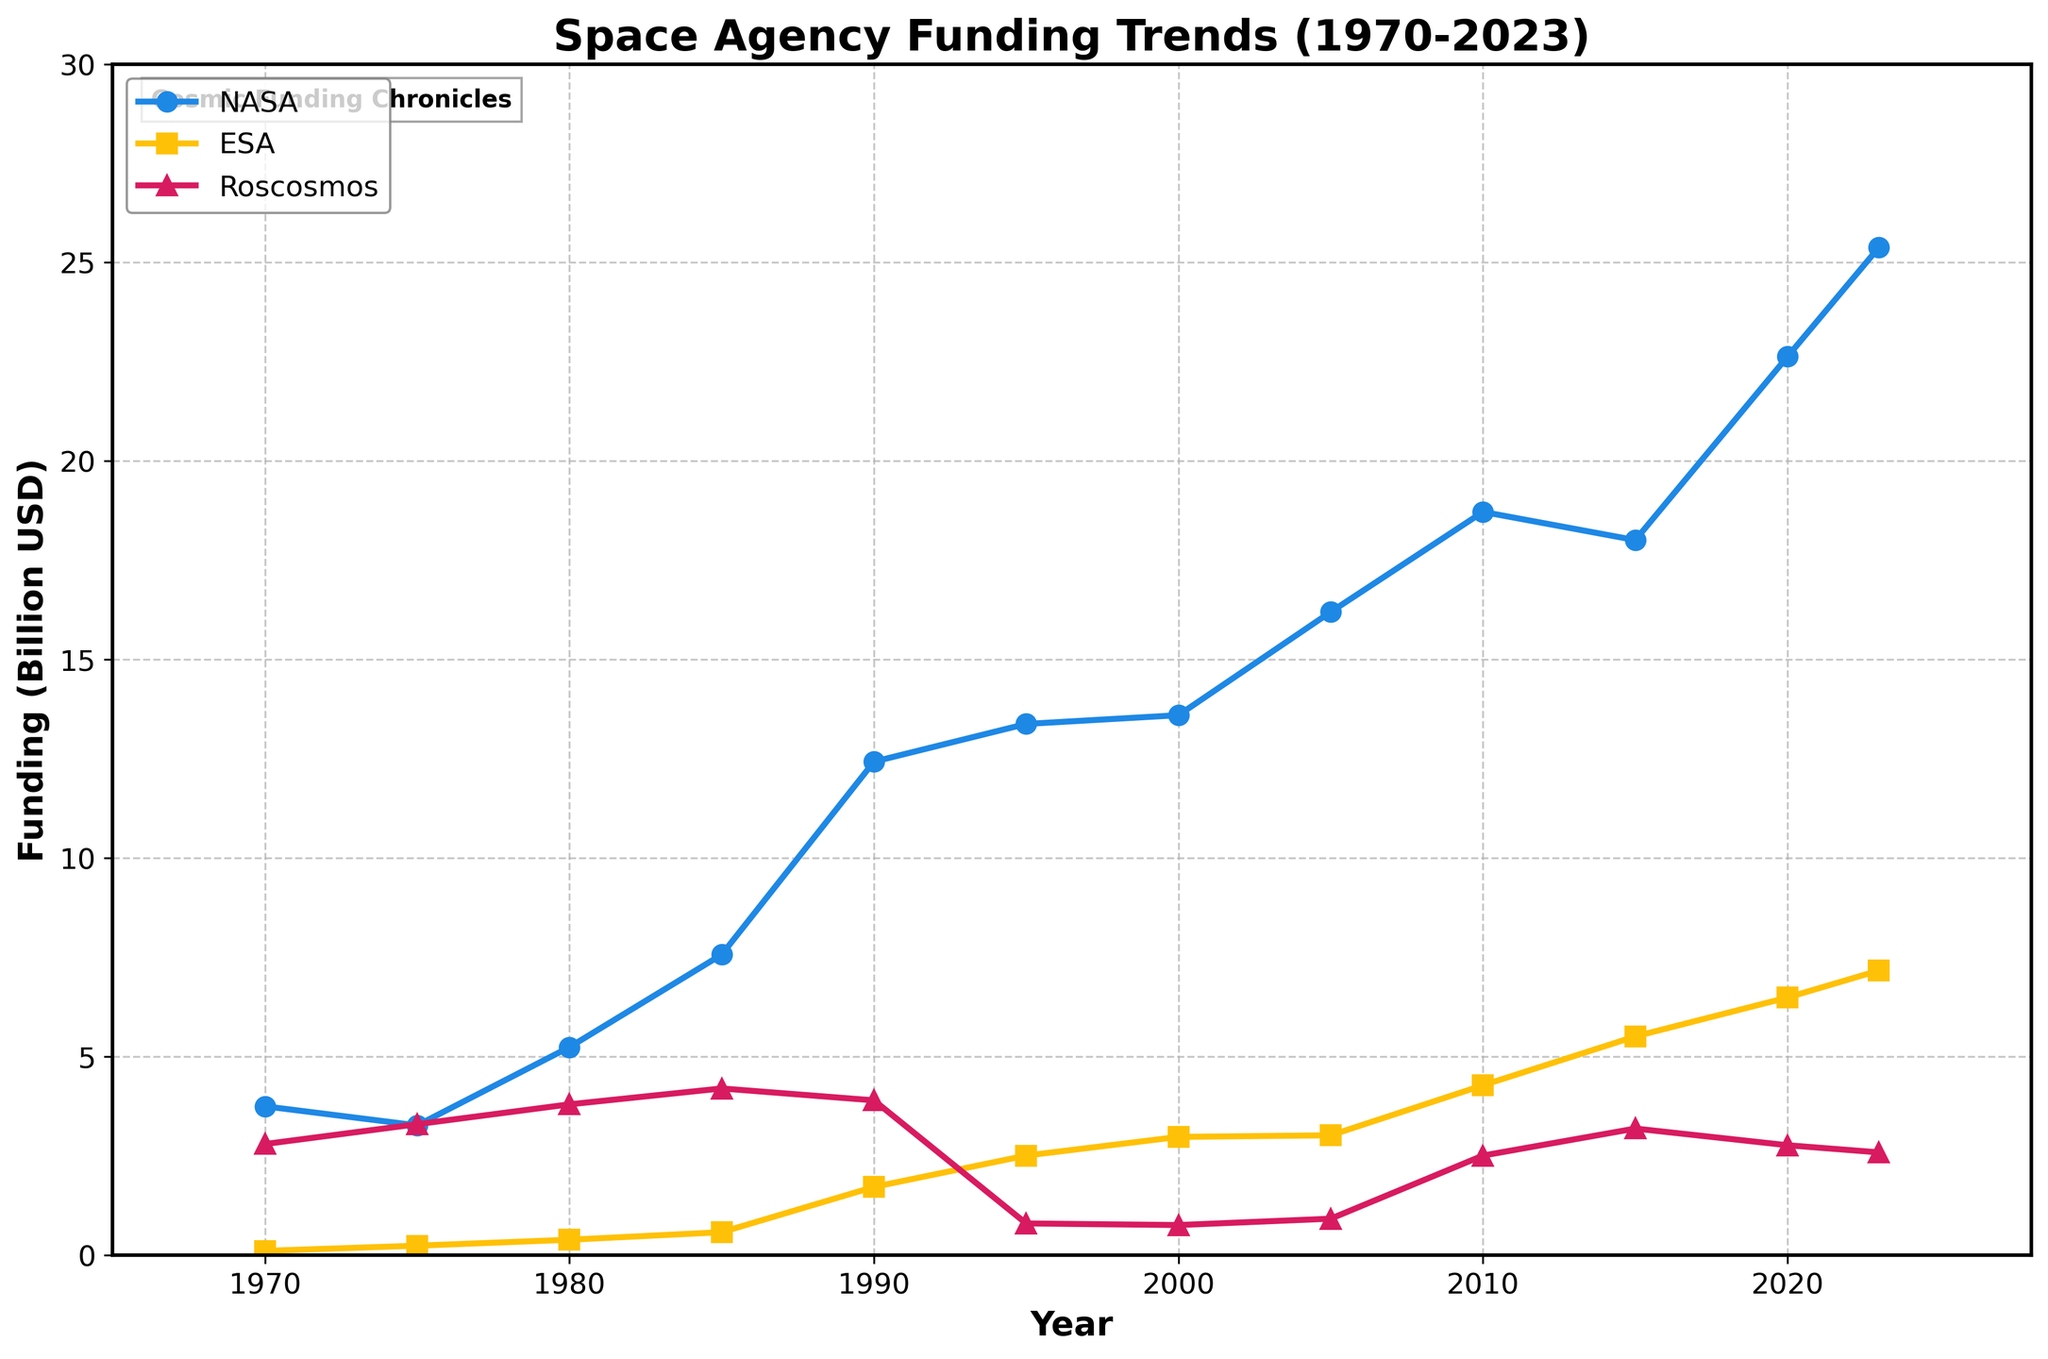What is the trend of NASA's funding from 1970 to 2023? The plot shows an upward trend in NASA's funding from around $3.75 billion in 1970 to around $25.38 billion in 2023. The increase is especially pronounced from the early 1990s onwards.
Answer: Upward trend Which agency had the lowest funding in the year 1995? In 1995, Roscosmos had the lowest funding at around $0.80 billion, while NASA and ESA had higher funding amounts.
Answer: Roscosmos How much did ESA's funding increase from 2010 to 2023? In 2010, ESA's funding was around $4.28 billion, and in 2023 it is around $7.17 billion. The difference is $7.17 billion - $4.28 billion = $2.89 billion.
Answer: $2.89 billion Between 1975 and 1985, which agency saw the greatest increase in funding? NASA's funding increased from $3.27 billion in 1975 to $7.57 billion in 1985, showing an increase of $4.30 billion. ESA's increase was $0.34 billion ($0.24 billion to $0.58 billion), and Roscosmos' increase was $0.90 billion ($3.30 billion to $4.20 billion).
Answer: NASA In which year did NASA first exceed $10 billion in funding? According to the plot, NASA's funding first exceeded $10 billion in 1990 with a value of $12.43 billion.
Answer: 1990 Compare the funding of ESA and Roscosmos in 2000. Which agency had higher funding and by how much? In 2000, ESA had $2.98 billion in funding while Roscosmos had $0.76 billion. The difference is $2.98 billion - $0.76 billion = $2.22 billion.
Answer: ESA, by $2.22 billion What is the general trend of Roscosmos' funding after 1990 compared to before 1990? Before 1990, Roscosmos' funding was generally stable or increasing slightly. After 1990, there was a significant drop, reaching its lowest around 1995, followed by a gradual recovery.
Answer: Trend drops after 1990 What is the average funding of ESA from 1970 to 2023? The funding values for ESA from 1970 to 2023 are $0.11, $0.24, $0.39, $0.58, $1.72, $2.51, $2.98, $3.02, $4.28, $5.51, $6.49, and $7.17 billion. Sum is 35.00 billion. There are 12 values. Average = sum / number of values = 35.00 / 12 = 2.92 billion.
Answer: $2.92 billion Which agency had the greatest volatility in its funding trend? Roscosmos exhibited the greatest volatility, with a significant drop post-1990 followed by a fluctuating recovery. NASA and ESA showed more consistent upward trends.
Answer: Roscosmos At what point did ESA's funding surpass $5 billion? ESA's funding surpassed $5 billion for the first time in the year 2015.
Answer: 2015 